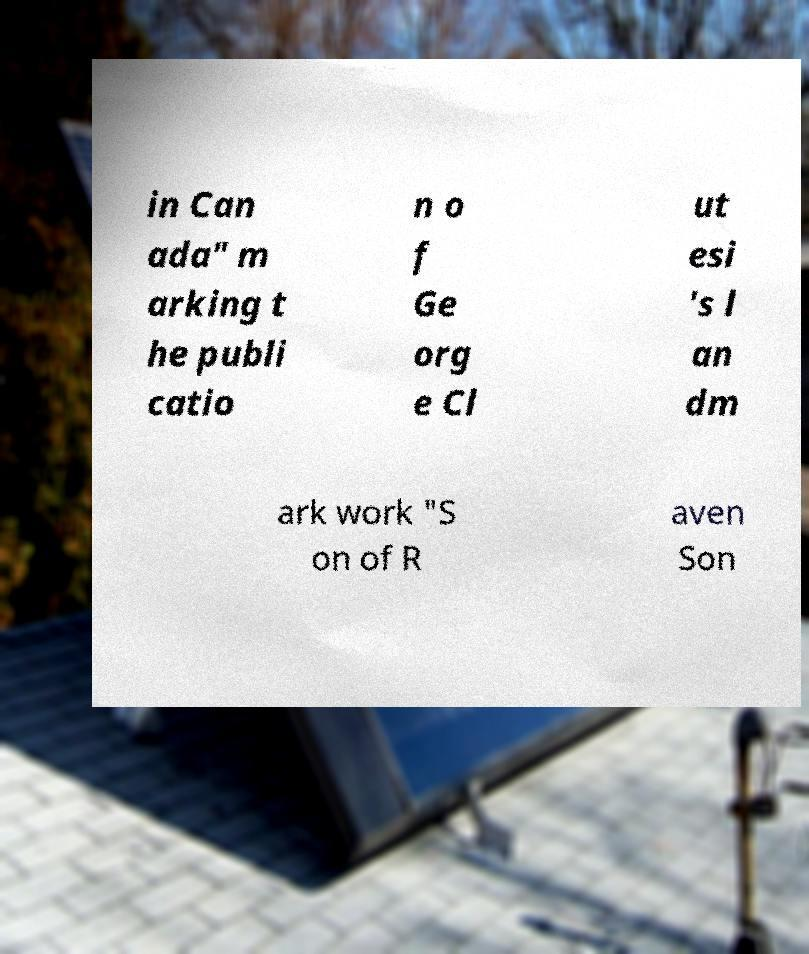I need the written content from this picture converted into text. Can you do that? in Can ada" m arking t he publi catio n o f Ge org e Cl ut esi 's l an dm ark work "S on of R aven Son 